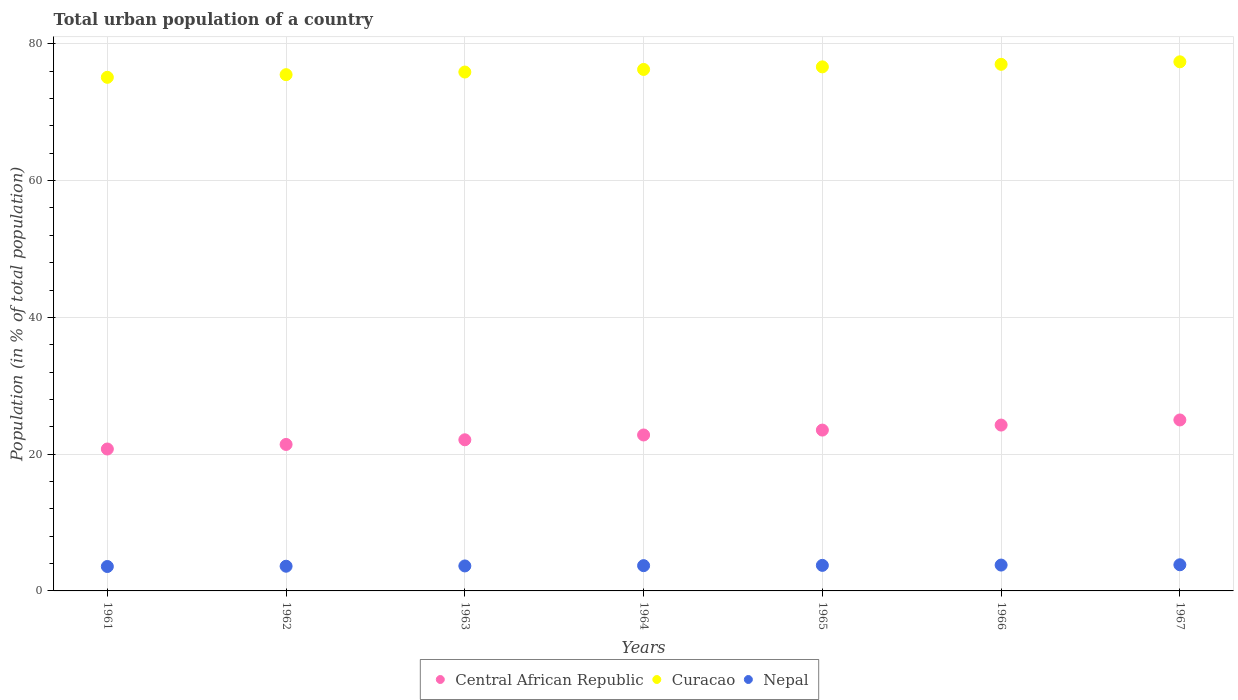What is the urban population in Curacao in 1962?
Offer a very short reply. 75.49. Across all years, what is the maximum urban population in Curacao?
Ensure brevity in your answer.  77.37. Across all years, what is the minimum urban population in Central African Republic?
Provide a succinct answer. 20.75. In which year was the urban population in Central African Republic maximum?
Ensure brevity in your answer.  1967. In which year was the urban population in Nepal minimum?
Give a very brief answer. 1961. What is the total urban population in Nepal in the graph?
Ensure brevity in your answer.  25.87. What is the difference between the urban population in Central African Republic in 1965 and that in 1967?
Give a very brief answer. -1.48. What is the difference between the urban population in Curacao in 1961 and the urban population in Nepal in 1965?
Provide a short and direct response. 71.37. What is the average urban population in Nepal per year?
Your response must be concise. 3.7. In the year 1965, what is the difference between the urban population in Nepal and urban population in Curacao?
Give a very brief answer. -72.89. In how many years, is the urban population in Curacao greater than 20 %?
Your answer should be compact. 7. What is the ratio of the urban population in Curacao in 1961 to that in 1962?
Your answer should be compact. 0.99. What is the difference between the highest and the second highest urban population in Nepal?
Provide a short and direct response. 0.04. What is the difference between the highest and the lowest urban population in Nepal?
Your response must be concise. 0.25. In how many years, is the urban population in Curacao greater than the average urban population in Curacao taken over all years?
Offer a very short reply. 4. Does the urban population in Curacao monotonically increase over the years?
Your answer should be very brief. Yes. How many dotlines are there?
Provide a short and direct response. 3. Are the values on the major ticks of Y-axis written in scientific E-notation?
Offer a very short reply. No. Does the graph contain grids?
Provide a short and direct response. Yes. Where does the legend appear in the graph?
Your answer should be very brief. Bottom center. What is the title of the graph?
Your answer should be very brief. Total urban population of a country. Does "Bulgaria" appear as one of the legend labels in the graph?
Give a very brief answer. No. What is the label or title of the Y-axis?
Give a very brief answer. Population (in % of total population). What is the Population (in % of total population) in Central African Republic in 1961?
Your answer should be very brief. 20.75. What is the Population (in % of total population) in Curacao in 1961?
Offer a very short reply. 75.1. What is the Population (in % of total population) in Nepal in 1961?
Keep it short and to the point. 3.57. What is the Population (in % of total population) in Central African Republic in 1962?
Provide a short and direct response. 21.42. What is the Population (in % of total population) of Curacao in 1962?
Ensure brevity in your answer.  75.49. What is the Population (in % of total population) in Nepal in 1962?
Your answer should be compact. 3.61. What is the Population (in % of total population) of Central African Republic in 1963?
Offer a terse response. 22.1. What is the Population (in % of total population) of Curacao in 1963?
Provide a short and direct response. 75.88. What is the Population (in % of total population) in Nepal in 1963?
Provide a succinct answer. 3.65. What is the Population (in % of total population) in Central African Republic in 1964?
Ensure brevity in your answer.  22.8. What is the Population (in % of total population) in Curacao in 1964?
Your response must be concise. 76.25. What is the Population (in % of total population) of Nepal in 1964?
Your response must be concise. 3.69. What is the Population (in % of total population) in Central African Republic in 1965?
Your response must be concise. 23.52. What is the Population (in % of total population) of Curacao in 1965?
Your response must be concise. 76.63. What is the Population (in % of total population) of Nepal in 1965?
Your answer should be compact. 3.74. What is the Population (in % of total population) of Central African Republic in 1966?
Offer a terse response. 24.25. What is the Population (in % of total population) in Curacao in 1966?
Provide a short and direct response. 77. What is the Population (in % of total population) of Nepal in 1966?
Your answer should be very brief. 3.78. What is the Population (in % of total population) of Curacao in 1967?
Offer a very short reply. 77.37. What is the Population (in % of total population) in Nepal in 1967?
Keep it short and to the point. 3.82. Across all years, what is the maximum Population (in % of total population) in Curacao?
Give a very brief answer. 77.37. Across all years, what is the maximum Population (in % of total population) of Nepal?
Your answer should be compact. 3.82. Across all years, what is the minimum Population (in % of total population) of Central African Republic?
Keep it short and to the point. 20.75. Across all years, what is the minimum Population (in % of total population) in Curacao?
Provide a short and direct response. 75.1. Across all years, what is the minimum Population (in % of total population) of Nepal?
Your answer should be compact. 3.57. What is the total Population (in % of total population) of Central African Republic in the graph?
Give a very brief answer. 159.84. What is the total Population (in % of total population) in Curacao in the graph?
Ensure brevity in your answer.  533.73. What is the total Population (in % of total population) in Nepal in the graph?
Offer a terse response. 25.87. What is the difference between the Population (in % of total population) in Central African Republic in 1961 and that in 1962?
Offer a very short reply. -0.67. What is the difference between the Population (in % of total population) of Curacao in 1961 and that in 1962?
Ensure brevity in your answer.  -0.39. What is the difference between the Population (in % of total population) in Nepal in 1961 and that in 1962?
Your answer should be very brief. -0.04. What is the difference between the Population (in % of total population) of Central African Republic in 1961 and that in 1963?
Your answer should be compact. -1.35. What is the difference between the Population (in % of total population) of Curacao in 1961 and that in 1963?
Give a very brief answer. -0.77. What is the difference between the Population (in % of total population) of Nepal in 1961 and that in 1963?
Offer a very short reply. -0.08. What is the difference between the Population (in % of total population) of Central African Republic in 1961 and that in 1964?
Provide a succinct answer. -2.05. What is the difference between the Population (in % of total population) in Curacao in 1961 and that in 1964?
Your answer should be compact. -1.15. What is the difference between the Population (in % of total population) in Nepal in 1961 and that in 1964?
Keep it short and to the point. -0.12. What is the difference between the Population (in % of total population) of Central African Republic in 1961 and that in 1965?
Your response must be concise. -2.77. What is the difference between the Population (in % of total population) in Curacao in 1961 and that in 1965?
Ensure brevity in your answer.  -1.53. What is the difference between the Population (in % of total population) in Nepal in 1961 and that in 1965?
Keep it short and to the point. -0.17. What is the difference between the Population (in % of total population) in Central African Republic in 1961 and that in 1966?
Your answer should be compact. -3.5. What is the difference between the Population (in % of total population) of Curacao in 1961 and that in 1966?
Your answer should be very brief. -1.9. What is the difference between the Population (in % of total population) in Nepal in 1961 and that in 1966?
Your response must be concise. -0.21. What is the difference between the Population (in % of total population) of Central African Republic in 1961 and that in 1967?
Your answer should be compact. -4.25. What is the difference between the Population (in % of total population) of Curacao in 1961 and that in 1967?
Provide a succinct answer. -2.27. What is the difference between the Population (in % of total population) of Nepal in 1961 and that in 1967?
Give a very brief answer. -0.25. What is the difference between the Population (in % of total population) of Central African Republic in 1962 and that in 1963?
Ensure brevity in your answer.  -0.68. What is the difference between the Population (in % of total population) in Curacao in 1962 and that in 1963?
Offer a very short reply. -0.39. What is the difference between the Population (in % of total population) of Nepal in 1962 and that in 1963?
Your answer should be very brief. -0.04. What is the difference between the Population (in % of total population) in Central African Republic in 1962 and that in 1964?
Make the answer very short. -1.39. What is the difference between the Population (in % of total population) in Curacao in 1962 and that in 1964?
Keep it short and to the point. -0.77. What is the difference between the Population (in % of total population) in Nepal in 1962 and that in 1964?
Give a very brief answer. -0.08. What is the difference between the Population (in % of total population) of Central African Republic in 1962 and that in 1965?
Offer a terse response. -2.1. What is the difference between the Population (in % of total population) of Curacao in 1962 and that in 1965?
Offer a terse response. -1.14. What is the difference between the Population (in % of total population) of Nepal in 1962 and that in 1965?
Provide a short and direct response. -0.12. What is the difference between the Population (in % of total population) of Central African Republic in 1962 and that in 1966?
Your answer should be compact. -2.83. What is the difference between the Population (in % of total population) of Curacao in 1962 and that in 1966?
Offer a terse response. -1.51. What is the difference between the Population (in % of total population) of Nepal in 1962 and that in 1966?
Your response must be concise. -0.17. What is the difference between the Population (in % of total population) in Central African Republic in 1962 and that in 1967?
Your response must be concise. -3.58. What is the difference between the Population (in % of total population) of Curacao in 1962 and that in 1967?
Ensure brevity in your answer.  -1.88. What is the difference between the Population (in % of total population) of Nepal in 1962 and that in 1967?
Offer a terse response. -0.21. What is the difference between the Population (in % of total population) of Central African Republic in 1963 and that in 1964?
Keep it short and to the point. -0.7. What is the difference between the Population (in % of total population) of Curacao in 1963 and that in 1964?
Provide a short and direct response. -0.38. What is the difference between the Population (in % of total population) in Nepal in 1963 and that in 1964?
Your answer should be very brief. -0.04. What is the difference between the Population (in % of total population) of Central African Republic in 1963 and that in 1965?
Your answer should be very brief. -1.42. What is the difference between the Population (in % of total population) of Curacao in 1963 and that in 1965?
Your answer should be compact. -0.76. What is the difference between the Population (in % of total population) of Nepal in 1963 and that in 1965?
Provide a short and direct response. -0.08. What is the difference between the Population (in % of total population) of Central African Republic in 1963 and that in 1966?
Your answer should be compact. -2.15. What is the difference between the Population (in % of total population) in Curacao in 1963 and that in 1966?
Offer a terse response. -1.13. What is the difference between the Population (in % of total population) of Nepal in 1963 and that in 1966?
Provide a short and direct response. -0.13. What is the difference between the Population (in % of total population) of Curacao in 1963 and that in 1967?
Your answer should be compact. -1.5. What is the difference between the Population (in % of total population) of Nepal in 1963 and that in 1967?
Make the answer very short. -0.17. What is the difference between the Population (in % of total population) of Central African Republic in 1964 and that in 1965?
Your response must be concise. -0.72. What is the difference between the Population (in % of total population) in Curacao in 1964 and that in 1965?
Offer a terse response. -0.38. What is the difference between the Population (in % of total population) of Nepal in 1964 and that in 1965?
Keep it short and to the point. -0.04. What is the difference between the Population (in % of total population) in Central African Republic in 1964 and that in 1966?
Provide a short and direct response. -1.45. What is the difference between the Population (in % of total population) in Curacao in 1964 and that in 1966?
Provide a succinct answer. -0.75. What is the difference between the Population (in % of total population) in Nepal in 1964 and that in 1966?
Provide a short and direct response. -0.09. What is the difference between the Population (in % of total population) in Central African Republic in 1964 and that in 1967?
Ensure brevity in your answer.  -2.2. What is the difference between the Population (in % of total population) of Curacao in 1964 and that in 1967?
Provide a short and direct response. -1.11. What is the difference between the Population (in % of total population) of Nepal in 1964 and that in 1967?
Make the answer very short. -0.13. What is the difference between the Population (in % of total population) in Central African Republic in 1965 and that in 1966?
Your answer should be very brief. -0.73. What is the difference between the Population (in % of total population) in Curacao in 1965 and that in 1966?
Provide a short and direct response. -0.37. What is the difference between the Population (in % of total population) in Nepal in 1965 and that in 1966?
Offer a very short reply. -0.04. What is the difference between the Population (in % of total population) in Central African Republic in 1965 and that in 1967?
Your answer should be compact. -1.48. What is the difference between the Population (in % of total population) in Curacao in 1965 and that in 1967?
Provide a short and direct response. -0.74. What is the difference between the Population (in % of total population) in Nepal in 1965 and that in 1967?
Your answer should be very brief. -0.09. What is the difference between the Population (in % of total population) of Central African Republic in 1966 and that in 1967?
Your answer should be very brief. -0.75. What is the difference between the Population (in % of total population) of Curacao in 1966 and that in 1967?
Keep it short and to the point. -0.37. What is the difference between the Population (in % of total population) of Nepal in 1966 and that in 1967?
Your response must be concise. -0.04. What is the difference between the Population (in % of total population) of Central African Republic in 1961 and the Population (in % of total population) of Curacao in 1962?
Your answer should be very brief. -54.74. What is the difference between the Population (in % of total population) of Central African Republic in 1961 and the Population (in % of total population) of Nepal in 1962?
Make the answer very short. 17.14. What is the difference between the Population (in % of total population) in Curacao in 1961 and the Population (in % of total population) in Nepal in 1962?
Your response must be concise. 71.49. What is the difference between the Population (in % of total population) of Central African Republic in 1961 and the Population (in % of total population) of Curacao in 1963?
Offer a terse response. -55.12. What is the difference between the Population (in % of total population) of Central African Republic in 1961 and the Population (in % of total population) of Nepal in 1963?
Provide a succinct answer. 17.1. What is the difference between the Population (in % of total population) of Curacao in 1961 and the Population (in % of total population) of Nepal in 1963?
Provide a short and direct response. 71.45. What is the difference between the Population (in % of total population) in Central African Republic in 1961 and the Population (in % of total population) in Curacao in 1964?
Make the answer very short. -55.5. What is the difference between the Population (in % of total population) in Central African Republic in 1961 and the Population (in % of total population) in Nepal in 1964?
Provide a succinct answer. 17.06. What is the difference between the Population (in % of total population) of Curacao in 1961 and the Population (in % of total population) of Nepal in 1964?
Keep it short and to the point. 71.41. What is the difference between the Population (in % of total population) in Central African Republic in 1961 and the Population (in % of total population) in Curacao in 1965?
Ensure brevity in your answer.  -55.88. What is the difference between the Population (in % of total population) in Central African Republic in 1961 and the Population (in % of total population) in Nepal in 1965?
Give a very brief answer. 17.01. What is the difference between the Population (in % of total population) of Curacao in 1961 and the Population (in % of total population) of Nepal in 1965?
Ensure brevity in your answer.  71.36. What is the difference between the Population (in % of total population) of Central African Republic in 1961 and the Population (in % of total population) of Curacao in 1966?
Provide a short and direct response. -56.25. What is the difference between the Population (in % of total population) in Central African Republic in 1961 and the Population (in % of total population) in Nepal in 1966?
Offer a terse response. 16.97. What is the difference between the Population (in % of total population) in Curacao in 1961 and the Population (in % of total population) in Nepal in 1966?
Provide a succinct answer. 71.32. What is the difference between the Population (in % of total population) of Central African Republic in 1961 and the Population (in % of total population) of Curacao in 1967?
Keep it short and to the point. -56.62. What is the difference between the Population (in % of total population) of Central African Republic in 1961 and the Population (in % of total population) of Nepal in 1967?
Your response must be concise. 16.93. What is the difference between the Population (in % of total population) of Curacao in 1961 and the Population (in % of total population) of Nepal in 1967?
Ensure brevity in your answer.  71.28. What is the difference between the Population (in % of total population) in Central African Republic in 1962 and the Population (in % of total population) in Curacao in 1963?
Provide a succinct answer. -54.46. What is the difference between the Population (in % of total population) of Central African Republic in 1962 and the Population (in % of total population) of Nepal in 1963?
Give a very brief answer. 17.77. What is the difference between the Population (in % of total population) in Curacao in 1962 and the Population (in % of total population) in Nepal in 1963?
Ensure brevity in your answer.  71.84. What is the difference between the Population (in % of total population) in Central African Republic in 1962 and the Population (in % of total population) in Curacao in 1964?
Keep it short and to the point. -54.84. What is the difference between the Population (in % of total population) of Central African Republic in 1962 and the Population (in % of total population) of Nepal in 1964?
Provide a short and direct response. 17.72. What is the difference between the Population (in % of total population) in Curacao in 1962 and the Population (in % of total population) in Nepal in 1964?
Your answer should be very brief. 71.8. What is the difference between the Population (in % of total population) of Central African Republic in 1962 and the Population (in % of total population) of Curacao in 1965?
Your answer should be compact. -55.21. What is the difference between the Population (in % of total population) in Central African Republic in 1962 and the Population (in % of total population) in Nepal in 1965?
Make the answer very short. 17.68. What is the difference between the Population (in % of total population) of Curacao in 1962 and the Population (in % of total population) of Nepal in 1965?
Keep it short and to the point. 71.75. What is the difference between the Population (in % of total population) in Central African Republic in 1962 and the Population (in % of total population) in Curacao in 1966?
Give a very brief answer. -55.59. What is the difference between the Population (in % of total population) in Central African Republic in 1962 and the Population (in % of total population) in Nepal in 1966?
Your answer should be very brief. 17.64. What is the difference between the Population (in % of total population) of Curacao in 1962 and the Population (in % of total population) of Nepal in 1966?
Your response must be concise. 71.71. What is the difference between the Population (in % of total population) in Central African Republic in 1962 and the Population (in % of total population) in Curacao in 1967?
Offer a terse response. -55.95. What is the difference between the Population (in % of total population) in Central African Republic in 1962 and the Population (in % of total population) in Nepal in 1967?
Keep it short and to the point. 17.59. What is the difference between the Population (in % of total population) in Curacao in 1962 and the Population (in % of total population) in Nepal in 1967?
Offer a terse response. 71.67. What is the difference between the Population (in % of total population) in Central African Republic in 1963 and the Population (in % of total population) in Curacao in 1964?
Make the answer very short. -54.16. What is the difference between the Population (in % of total population) of Central African Republic in 1963 and the Population (in % of total population) of Nepal in 1964?
Offer a very short reply. 18.41. What is the difference between the Population (in % of total population) in Curacao in 1963 and the Population (in % of total population) in Nepal in 1964?
Provide a succinct answer. 72.18. What is the difference between the Population (in % of total population) in Central African Republic in 1963 and the Population (in % of total population) in Curacao in 1965?
Your response must be concise. -54.53. What is the difference between the Population (in % of total population) of Central African Republic in 1963 and the Population (in % of total population) of Nepal in 1965?
Your answer should be compact. 18.36. What is the difference between the Population (in % of total population) of Curacao in 1963 and the Population (in % of total population) of Nepal in 1965?
Your response must be concise. 72.14. What is the difference between the Population (in % of total population) of Central African Republic in 1963 and the Population (in % of total population) of Curacao in 1966?
Offer a terse response. -54.9. What is the difference between the Population (in % of total population) of Central African Republic in 1963 and the Population (in % of total population) of Nepal in 1966?
Provide a short and direct response. 18.32. What is the difference between the Population (in % of total population) in Curacao in 1963 and the Population (in % of total population) in Nepal in 1966?
Give a very brief answer. 72.09. What is the difference between the Population (in % of total population) in Central African Republic in 1963 and the Population (in % of total population) in Curacao in 1967?
Offer a terse response. -55.27. What is the difference between the Population (in % of total population) in Central African Republic in 1963 and the Population (in % of total population) in Nepal in 1967?
Give a very brief answer. 18.28. What is the difference between the Population (in % of total population) in Curacao in 1963 and the Population (in % of total population) in Nepal in 1967?
Provide a succinct answer. 72.05. What is the difference between the Population (in % of total population) in Central African Republic in 1964 and the Population (in % of total population) in Curacao in 1965?
Your answer should be very brief. -53.83. What is the difference between the Population (in % of total population) of Central African Republic in 1964 and the Population (in % of total population) of Nepal in 1965?
Offer a very short reply. 19.07. What is the difference between the Population (in % of total population) in Curacao in 1964 and the Population (in % of total population) in Nepal in 1965?
Your answer should be compact. 72.52. What is the difference between the Population (in % of total population) of Central African Republic in 1964 and the Population (in % of total population) of Curacao in 1966?
Keep it short and to the point. -54.2. What is the difference between the Population (in % of total population) of Central African Republic in 1964 and the Population (in % of total population) of Nepal in 1966?
Provide a succinct answer. 19.02. What is the difference between the Population (in % of total population) in Curacao in 1964 and the Population (in % of total population) in Nepal in 1966?
Your answer should be compact. 72.47. What is the difference between the Population (in % of total population) in Central African Republic in 1964 and the Population (in % of total population) in Curacao in 1967?
Offer a terse response. -54.57. What is the difference between the Population (in % of total population) of Central African Republic in 1964 and the Population (in % of total population) of Nepal in 1967?
Provide a short and direct response. 18.98. What is the difference between the Population (in % of total population) of Curacao in 1964 and the Population (in % of total population) of Nepal in 1967?
Offer a very short reply. 72.43. What is the difference between the Population (in % of total population) of Central African Republic in 1965 and the Population (in % of total population) of Curacao in 1966?
Give a very brief answer. -53.48. What is the difference between the Population (in % of total population) in Central African Republic in 1965 and the Population (in % of total population) in Nepal in 1966?
Ensure brevity in your answer.  19.74. What is the difference between the Population (in % of total population) in Curacao in 1965 and the Population (in % of total population) in Nepal in 1966?
Your answer should be compact. 72.85. What is the difference between the Population (in % of total population) in Central African Republic in 1965 and the Population (in % of total population) in Curacao in 1967?
Your answer should be very brief. -53.85. What is the difference between the Population (in % of total population) of Central African Republic in 1965 and the Population (in % of total population) of Nepal in 1967?
Your response must be concise. 19.7. What is the difference between the Population (in % of total population) in Curacao in 1965 and the Population (in % of total population) in Nepal in 1967?
Give a very brief answer. 72.81. What is the difference between the Population (in % of total population) of Central African Republic in 1966 and the Population (in % of total population) of Curacao in 1967?
Your response must be concise. -53.12. What is the difference between the Population (in % of total population) in Central African Republic in 1966 and the Population (in % of total population) in Nepal in 1967?
Offer a terse response. 20.43. What is the difference between the Population (in % of total population) of Curacao in 1966 and the Population (in % of total population) of Nepal in 1967?
Provide a short and direct response. 73.18. What is the average Population (in % of total population) in Central African Republic per year?
Give a very brief answer. 22.83. What is the average Population (in % of total population) in Curacao per year?
Your response must be concise. 76.25. What is the average Population (in % of total population) of Nepal per year?
Offer a very short reply. 3.7. In the year 1961, what is the difference between the Population (in % of total population) in Central African Republic and Population (in % of total population) in Curacao?
Your answer should be very brief. -54.35. In the year 1961, what is the difference between the Population (in % of total population) in Central African Republic and Population (in % of total population) in Nepal?
Your response must be concise. 17.18. In the year 1961, what is the difference between the Population (in % of total population) in Curacao and Population (in % of total population) in Nepal?
Provide a short and direct response. 71.53. In the year 1962, what is the difference between the Population (in % of total population) in Central African Republic and Population (in % of total population) in Curacao?
Offer a very short reply. -54.07. In the year 1962, what is the difference between the Population (in % of total population) in Central African Republic and Population (in % of total population) in Nepal?
Ensure brevity in your answer.  17.81. In the year 1962, what is the difference between the Population (in % of total population) in Curacao and Population (in % of total population) in Nepal?
Make the answer very short. 71.88. In the year 1963, what is the difference between the Population (in % of total population) of Central African Republic and Population (in % of total population) of Curacao?
Provide a succinct answer. -53.77. In the year 1963, what is the difference between the Population (in % of total population) of Central African Republic and Population (in % of total population) of Nepal?
Your answer should be compact. 18.45. In the year 1963, what is the difference between the Population (in % of total population) in Curacao and Population (in % of total population) in Nepal?
Keep it short and to the point. 72.22. In the year 1964, what is the difference between the Population (in % of total population) of Central African Republic and Population (in % of total population) of Curacao?
Your answer should be very brief. -53.45. In the year 1964, what is the difference between the Population (in % of total population) in Central African Republic and Population (in % of total population) in Nepal?
Offer a very short reply. 19.11. In the year 1964, what is the difference between the Population (in % of total population) of Curacao and Population (in % of total population) of Nepal?
Make the answer very short. 72.56. In the year 1965, what is the difference between the Population (in % of total population) in Central African Republic and Population (in % of total population) in Curacao?
Your response must be concise. -53.11. In the year 1965, what is the difference between the Population (in % of total population) in Central African Republic and Population (in % of total population) in Nepal?
Make the answer very short. 19.78. In the year 1965, what is the difference between the Population (in % of total population) of Curacao and Population (in % of total population) of Nepal?
Your answer should be compact. 72.89. In the year 1966, what is the difference between the Population (in % of total population) in Central African Republic and Population (in % of total population) in Curacao?
Provide a succinct answer. -52.75. In the year 1966, what is the difference between the Population (in % of total population) in Central African Republic and Population (in % of total population) in Nepal?
Provide a short and direct response. 20.47. In the year 1966, what is the difference between the Population (in % of total population) of Curacao and Population (in % of total population) of Nepal?
Your answer should be compact. 73.22. In the year 1967, what is the difference between the Population (in % of total population) in Central African Republic and Population (in % of total population) in Curacao?
Keep it short and to the point. -52.37. In the year 1967, what is the difference between the Population (in % of total population) of Central African Republic and Population (in % of total population) of Nepal?
Keep it short and to the point. 21.18. In the year 1967, what is the difference between the Population (in % of total population) in Curacao and Population (in % of total population) in Nepal?
Your response must be concise. 73.55. What is the ratio of the Population (in % of total population) of Central African Republic in 1961 to that in 1962?
Offer a very short reply. 0.97. What is the ratio of the Population (in % of total population) in Curacao in 1961 to that in 1962?
Make the answer very short. 0.99. What is the ratio of the Population (in % of total population) of Nepal in 1961 to that in 1962?
Provide a succinct answer. 0.99. What is the ratio of the Population (in % of total population) in Central African Republic in 1961 to that in 1963?
Offer a terse response. 0.94. What is the ratio of the Population (in % of total population) in Nepal in 1961 to that in 1963?
Keep it short and to the point. 0.98. What is the ratio of the Population (in % of total population) of Central African Republic in 1961 to that in 1964?
Your response must be concise. 0.91. What is the ratio of the Population (in % of total population) in Curacao in 1961 to that in 1964?
Make the answer very short. 0.98. What is the ratio of the Population (in % of total population) in Nepal in 1961 to that in 1964?
Provide a succinct answer. 0.97. What is the ratio of the Population (in % of total population) of Central African Republic in 1961 to that in 1965?
Offer a very short reply. 0.88. What is the ratio of the Population (in % of total population) in Curacao in 1961 to that in 1965?
Make the answer very short. 0.98. What is the ratio of the Population (in % of total population) of Nepal in 1961 to that in 1965?
Provide a short and direct response. 0.96. What is the ratio of the Population (in % of total population) in Central African Republic in 1961 to that in 1966?
Your answer should be very brief. 0.86. What is the ratio of the Population (in % of total population) of Curacao in 1961 to that in 1966?
Give a very brief answer. 0.98. What is the ratio of the Population (in % of total population) in Nepal in 1961 to that in 1966?
Ensure brevity in your answer.  0.94. What is the ratio of the Population (in % of total population) of Central African Republic in 1961 to that in 1967?
Your answer should be compact. 0.83. What is the ratio of the Population (in % of total population) of Curacao in 1961 to that in 1967?
Offer a terse response. 0.97. What is the ratio of the Population (in % of total population) in Nepal in 1961 to that in 1967?
Provide a short and direct response. 0.93. What is the ratio of the Population (in % of total population) of Central African Republic in 1962 to that in 1963?
Offer a terse response. 0.97. What is the ratio of the Population (in % of total population) in Central African Republic in 1962 to that in 1964?
Keep it short and to the point. 0.94. What is the ratio of the Population (in % of total population) of Curacao in 1962 to that in 1964?
Your answer should be compact. 0.99. What is the ratio of the Population (in % of total population) of Nepal in 1962 to that in 1964?
Make the answer very short. 0.98. What is the ratio of the Population (in % of total population) of Central African Republic in 1962 to that in 1965?
Your answer should be compact. 0.91. What is the ratio of the Population (in % of total population) of Curacao in 1962 to that in 1965?
Provide a short and direct response. 0.99. What is the ratio of the Population (in % of total population) in Nepal in 1962 to that in 1965?
Make the answer very short. 0.97. What is the ratio of the Population (in % of total population) of Central African Republic in 1962 to that in 1966?
Provide a succinct answer. 0.88. What is the ratio of the Population (in % of total population) of Curacao in 1962 to that in 1966?
Give a very brief answer. 0.98. What is the ratio of the Population (in % of total population) in Nepal in 1962 to that in 1966?
Keep it short and to the point. 0.96. What is the ratio of the Population (in % of total population) in Central African Republic in 1962 to that in 1967?
Make the answer very short. 0.86. What is the ratio of the Population (in % of total population) in Curacao in 1962 to that in 1967?
Give a very brief answer. 0.98. What is the ratio of the Population (in % of total population) of Nepal in 1962 to that in 1967?
Keep it short and to the point. 0.94. What is the ratio of the Population (in % of total population) in Central African Republic in 1963 to that in 1964?
Keep it short and to the point. 0.97. What is the ratio of the Population (in % of total population) of Curacao in 1963 to that in 1964?
Ensure brevity in your answer.  0.99. What is the ratio of the Population (in % of total population) in Nepal in 1963 to that in 1964?
Give a very brief answer. 0.99. What is the ratio of the Population (in % of total population) in Central African Republic in 1963 to that in 1965?
Offer a very short reply. 0.94. What is the ratio of the Population (in % of total population) in Curacao in 1963 to that in 1965?
Keep it short and to the point. 0.99. What is the ratio of the Population (in % of total population) in Nepal in 1963 to that in 1965?
Your answer should be compact. 0.98. What is the ratio of the Population (in % of total population) in Central African Republic in 1963 to that in 1966?
Offer a very short reply. 0.91. What is the ratio of the Population (in % of total population) in Curacao in 1963 to that in 1966?
Provide a short and direct response. 0.99. What is the ratio of the Population (in % of total population) in Nepal in 1963 to that in 1966?
Offer a terse response. 0.97. What is the ratio of the Population (in % of total population) of Central African Republic in 1963 to that in 1967?
Give a very brief answer. 0.88. What is the ratio of the Population (in % of total population) in Curacao in 1963 to that in 1967?
Keep it short and to the point. 0.98. What is the ratio of the Population (in % of total population) in Nepal in 1963 to that in 1967?
Provide a succinct answer. 0.96. What is the ratio of the Population (in % of total population) in Central African Republic in 1964 to that in 1965?
Offer a very short reply. 0.97. What is the ratio of the Population (in % of total population) of Curacao in 1964 to that in 1965?
Provide a succinct answer. 1. What is the ratio of the Population (in % of total population) of Nepal in 1964 to that in 1965?
Ensure brevity in your answer.  0.99. What is the ratio of the Population (in % of total population) of Central African Republic in 1964 to that in 1966?
Your response must be concise. 0.94. What is the ratio of the Population (in % of total population) in Curacao in 1964 to that in 1966?
Ensure brevity in your answer.  0.99. What is the ratio of the Population (in % of total population) of Nepal in 1964 to that in 1966?
Provide a short and direct response. 0.98. What is the ratio of the Population (in % of total population) in Central African Republic in 1964 to that in 1967?
Give a very brief answer. 0.91. What is the ratio of the Population (in % of total population) in Curacao in 1964 to that in 1967?
Your response must be concise. 0.99. What is the ratio of the Population (in % of total population) of Nepal in 1964 to that in 1967?
Offer a very short reply. 0.97. What is the ratio of the Population (in % of total population) in Central African Republic in 1965 to that in 1966?
Make the answer very short. 0.97. What is the ratio of the Population (in % of total population) of Central African Republic in 1965 to that in 1967?
Your response must be concise. 0.94. What is the ratio of the Population (in % of total population) in Curacao in 1965 to that in 1967?
Provide a short and direct response. 0.99. What is the ratio of the Population (in % of total population) of Nepal in 1965 to that in 1967?
Ensure brevity in your answer.  0.98. What is the ratio of the Population (in % of total population) of Central African Republic in 1966 to that in 1967?
Your answer should be very brief. 0.97. What is the ratio of the Population (in % of total population) of Curacao in 1966 to that in 1967?
Your answer should be very brief. 1. What is the ratio of the Population (in % of total population) of Nepal in 1966 to that in 1967?
Your answer should be very brief. 0.99. What is the difference between the highest and the second highest Population (in % of total population) in Central African Republic?
Your answer should be compact. 0.75. What is the difference between the highest and the second highest Population (in % of total population) in Curacao?
Your answer should be compact. 0.37. What is the difference between the highest and the second highest Population (in % of total population) in Nepal?
Offer a very short reply. 0.04. What is the difference between the highest and the lowest Population (in % of total population) in Central African Republic?
Make the answer very short. 4.25. What is the difference between the highest and the lowest Population (in % of total population) in Curacao?
Ensure brevity in your answer.  2.27. What is the difference between the highest and the lowest Population (in % of total population) of Nepal?
Your answer should be very brief. 0.25. 